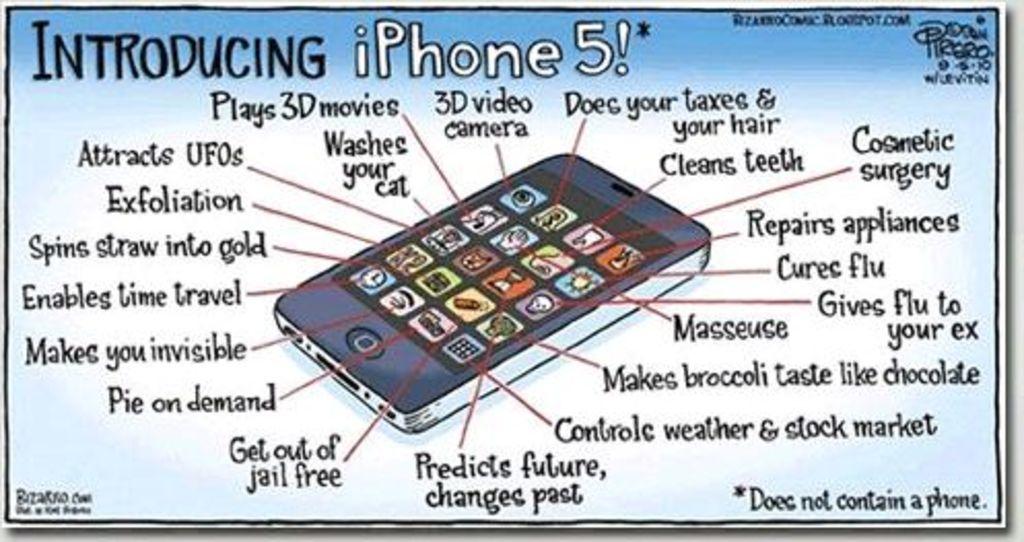Introducing what kind of phone?
Your answer should be very brief. Iphone 5. What are three of the features out of all of the features shown?
Make the answer very short. Unanswerable. 